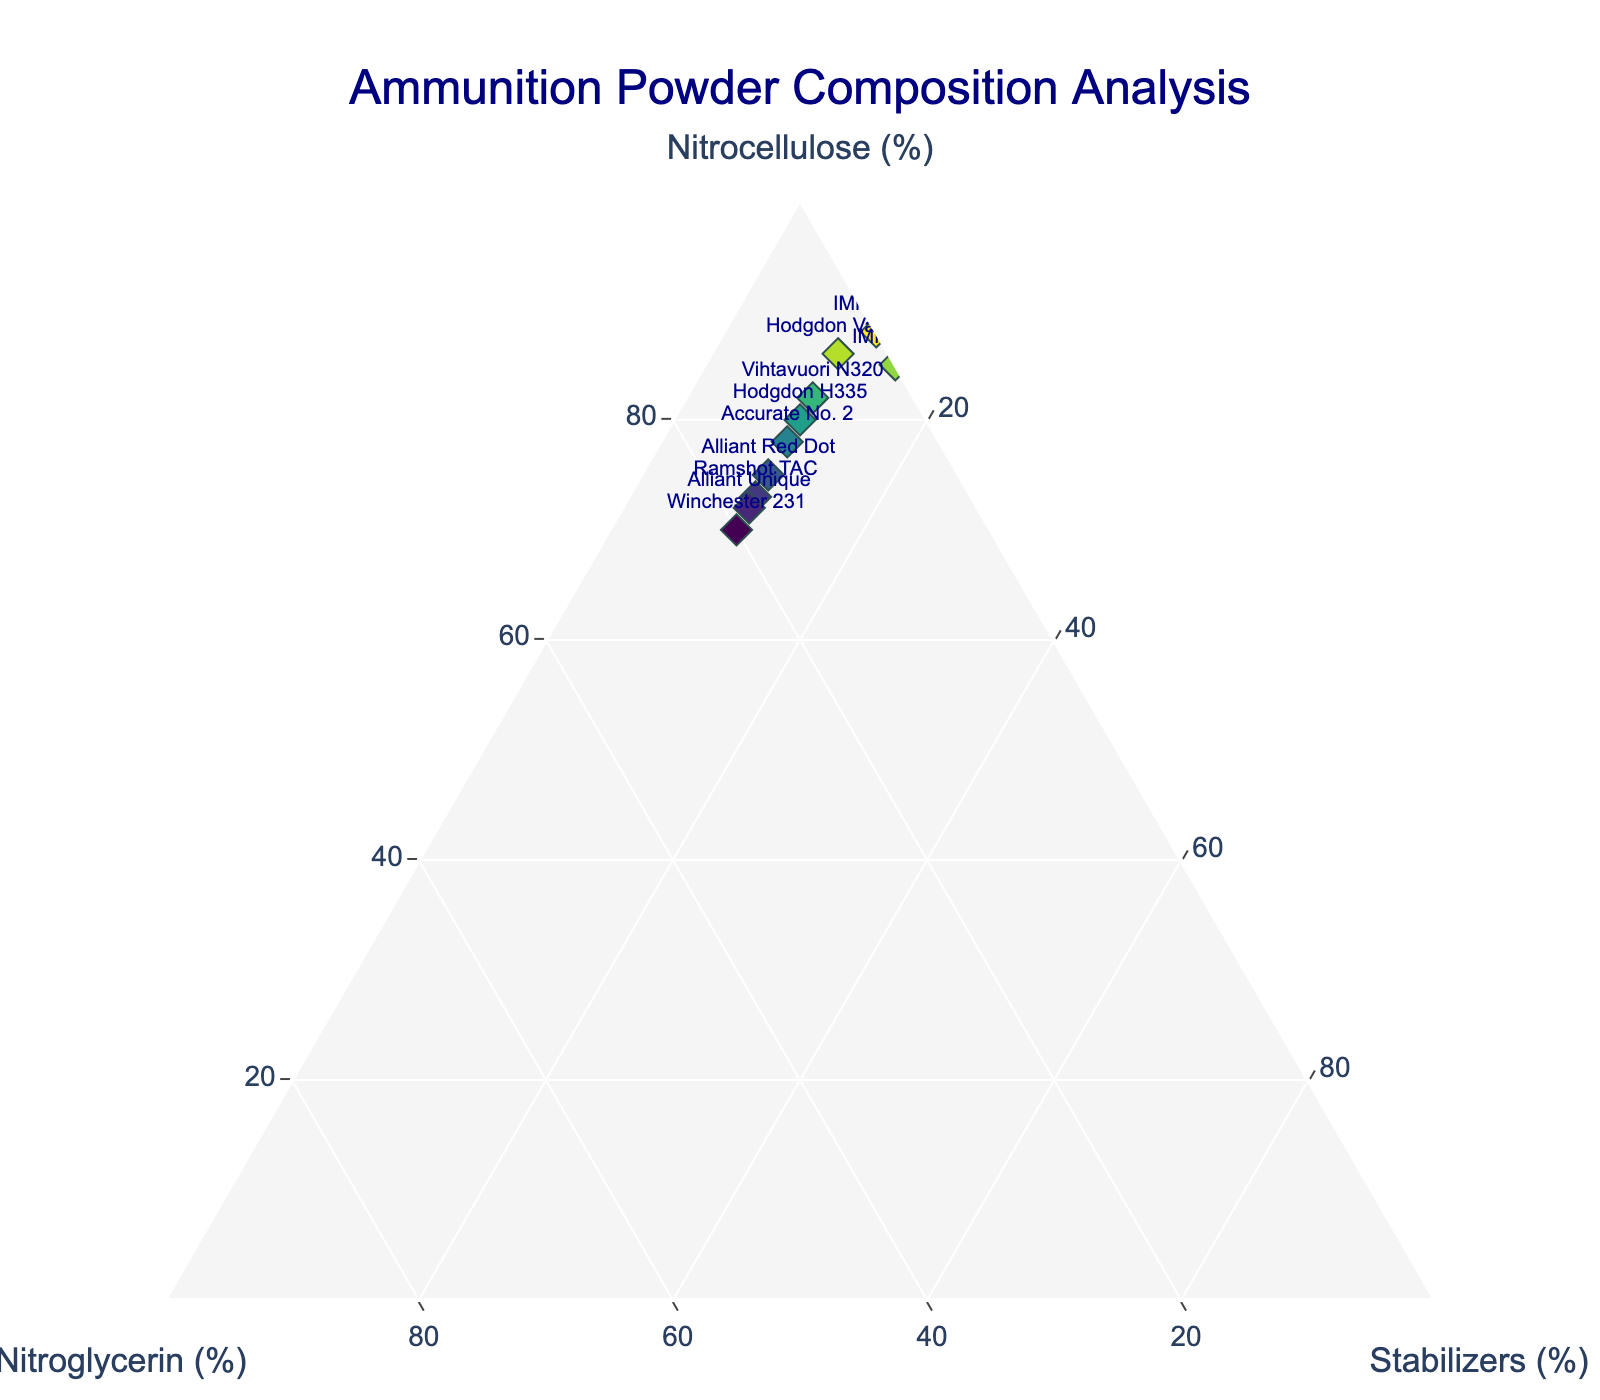Which component is the title of the figure focused on? The title of the figure, "Ammunition Powder Composition Analysis," indicates that the figure is focused on analyzing the composition of different components of ammunition powder. The main components are nitrocellulose, nitroglycerin, and stabilizers.
Answer: Ammunition powder composition Which powder has the highest nitrocellulose percentage? Looking at the vertices of the ternary plot for nitrocellulose, the position that is closest to the nitrocellulose axis represents the component with the highest percentage of nitrocellulose.
Answer: IMR 4227 How many components contain exactly 10% stabilizers? By examining the text labels near the data points, we can count the number of components with a stabilizer percentage of 10%.
Answer: 7 What are the percentages of nitrocellulose, nitroglycerin, and stabilizers for "Hodgdon Varget"? Locate the data point labeled "Hodgdon Varget" on the ternary plot, and read the percentages from the plot or the data table used to generate the plot.
Answer: 86% nitrocellulose, 4% nitroglycerin, 10% stabilizers Which powder is closest to having equal proportions of nitrocellulose and nitroglycerin? Examine the data points near the diagonal line (where nitrocellulose and nitroglycerin would be nearly equal), and identify the one that is closest to this line.
Answer: Accurate No. 2 (78% nitrocellulose, 12% nitroglycerin) Which component has the least variance in the proportion of stabilizers? By visually inspecting the spread of the data points in the direction of the stabilizer axis, identify which percentage value for stabilizers appears most frequently with minimal spread.
Answer: Stabilizers (most components have 10%) Compare the nitrocellulose and nitroglycerin content between "Alliant Red Dot" and "Winchester 231". Which has a higher percentage of nitroglycerin? By locating "Alliant Red Dot" and "Winchester 231" on the plot, compare their positions along the nitroglycerin axis.
Answer: Winchester 231 (20% vs. 15%) What is the average percentage of nitrocellulose across all components? Sum the percentages of nitrocellulose for all ten components, then divide by the number of components. Calculation: (85 + 80 + 75 + 70 + 82 + 78 + 73 + 88 + 86 + 72) ÷ 10 = 78.9%
Answer: 78.9% Which two components have both equal percentages of stabilizers and different nitrocellulose percentages? Identify the components with identical stabilizer percentages and then compare their nitrocellulose percentages.
Answer: Hodgdon H335 and Accurate No. 2 (both have 10% stabilizers but different nitrocellulose) 